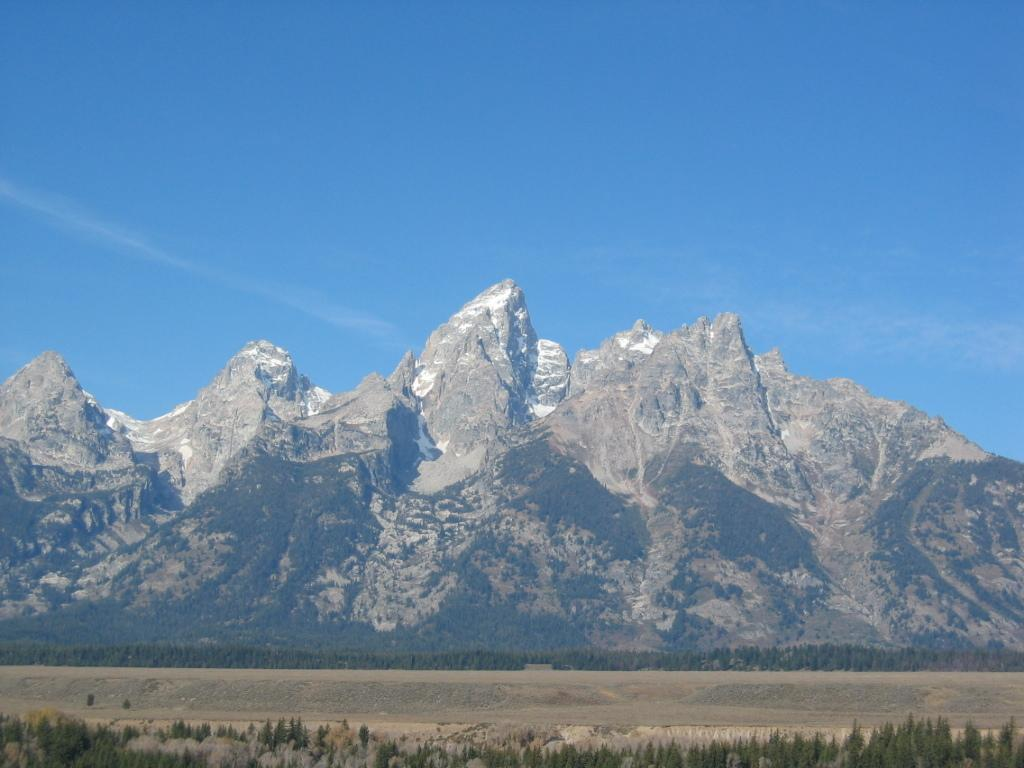What is the main feature in the center of the image? There are mountains in the center of the image. Are there any other natural elements in the image? Yes, there is a group of trees in the image. What part of the sky is visible in the image? The sky is visible in the image. How would you describe the sky's appearance in the image? The sky appears to be cloudy in the image. What type of channel can be seen running through the mountains in the image? There is no channel visible in the image; it only shows mountains and a group of trees. 